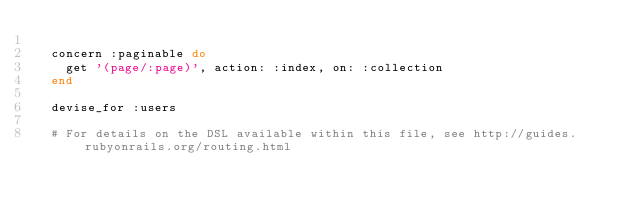<code> <loc_0><loc_0><loc_500><loc_500><_Ruby_>
  concern :paginable do
    get '(page/:page)', action: :index, on: :collection
  end

  devise_for :users

  # For details on the DSL available within this file, see http://guides.rubyonrails.org/routing.html
</code> 